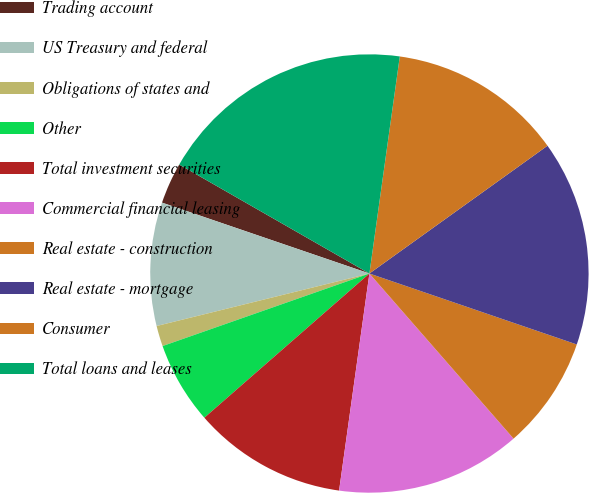Convert chart. <chart><loc_0><loc_0><loc_500><loc_500><pie_chart><fcel>Trading account<fcel>US Treasury and federal<fcel>Obligations of states and<fcel>Other<fcel>Total investment securities<fcel>Commercial financial leasing<fcel>Real estate - construction<fcel>Real estate - mortgage<fcel>Consumer<fcel>Total loans and leases<nl><fcel>3.04%<fcel>9.09%<fcel>1.52%<fcel>6.06%<fcel>11.36%<fcel>13.63%<fcel>8.33%<fcel>15.15%<fcel>12.88%<fcel>18.93%<nl></chart> 